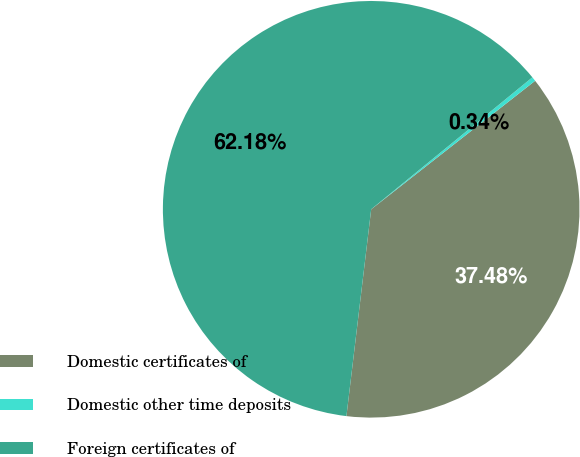Convert chart to OTSL. <chart><loc_0><loc_0><loc_500><loc_500><pie_chart><fcel>Domestic certificates of<fcel>Domestic other time deposits<fcel>Foreign certificates of<nl><fcel>37.48%<fcel>0.34%<fcel>62.19%<nl></chart> 